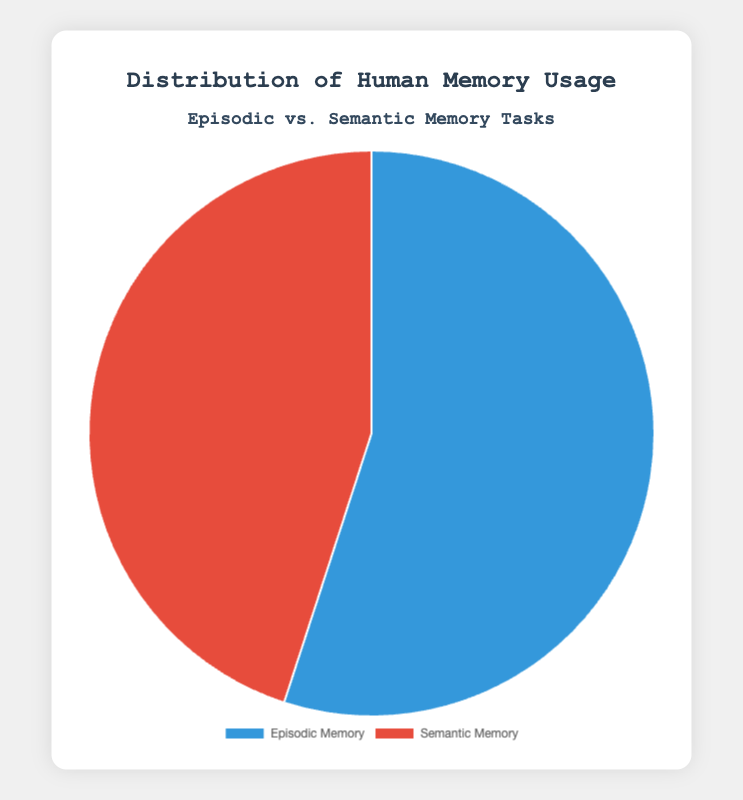What is the percentage usage of Episodic Memory? Look at the pie chart section labeled 'Episodic Memory.' The chart shows that Episodic Memory accounts for 55% of the total memory usage.
Answer: 55% How much more is Episodic Memory usage compared to Semantic Memory usage? Subtract the percentage of Semantic Memory usage from Episodic Memory usage. Episodic Memory is 55%, Semantic Memory is 45%, so 55% - 45% = 10%.
Answer: 10% What is the combined usage percentage of Episodic Memory and Semantic Memory? Add the usage percentages of both memory types together: 55% for Episodic Memory and 45% for Semantic Memory. 55% + 45% = 100%.
Answer: 100% Which type of memory has lesser usage in the tasks? Compare the two percentages shown in the pie chart. Semantic Memory has 45% while Episodic Memory has 55%. Since 45% < 55%, Semantic Memory has lesser usage.
Answer: Semantic Memory What is the ratio of Episodic Memory usage to Semantic Memory usage? Divide the percentage of Episodic Memory by the percentage of Semantic Memory. 55% / 45% = 1.22 (rounded to two decimal places).
Answer: 1.22 Is the usage percentage of Episodic Memory greater than half? The pie chart shows 55% for Episodic Memory which is more than half of 100%.
Answer: Yes If you combine the visual colors representing each memory type into a single bar, what would the longer section of the bar represent? The pie chart uses blue for Episodic Memory and red for Semantic Memory. Since Episodic Memory has a higher percentage (55%), the blue section would be longer.
Answer: Episodic Memory How does the color scheme help in distinguishing between Episodic and Semantic Memory tasks? The chart uses different colors for each memory type: blue for Episodic Memory and red for Semantic Memory, making it easy to visually distinguish between them.
Answer: Different colors: blue and red Which memory type's task has a percentage closer to an equal split of the dataset? 50% is an equal split. Semantic Memory at 45% is closer to 50% than Episodic Memory at 55%.
Answer: Semantic Memory If the total memory usage were scaled down to 50%, what would be the individual usage percentages for Episodic and Semantic Memory? Scale the percentages proportionally: (55% / 100%) * 50% = 27.5% for Episodic, and (45% / 100%) * 50% = 22.5% for Semantic.
Answer: 27.5% Episodic, 22.5% Semantic 